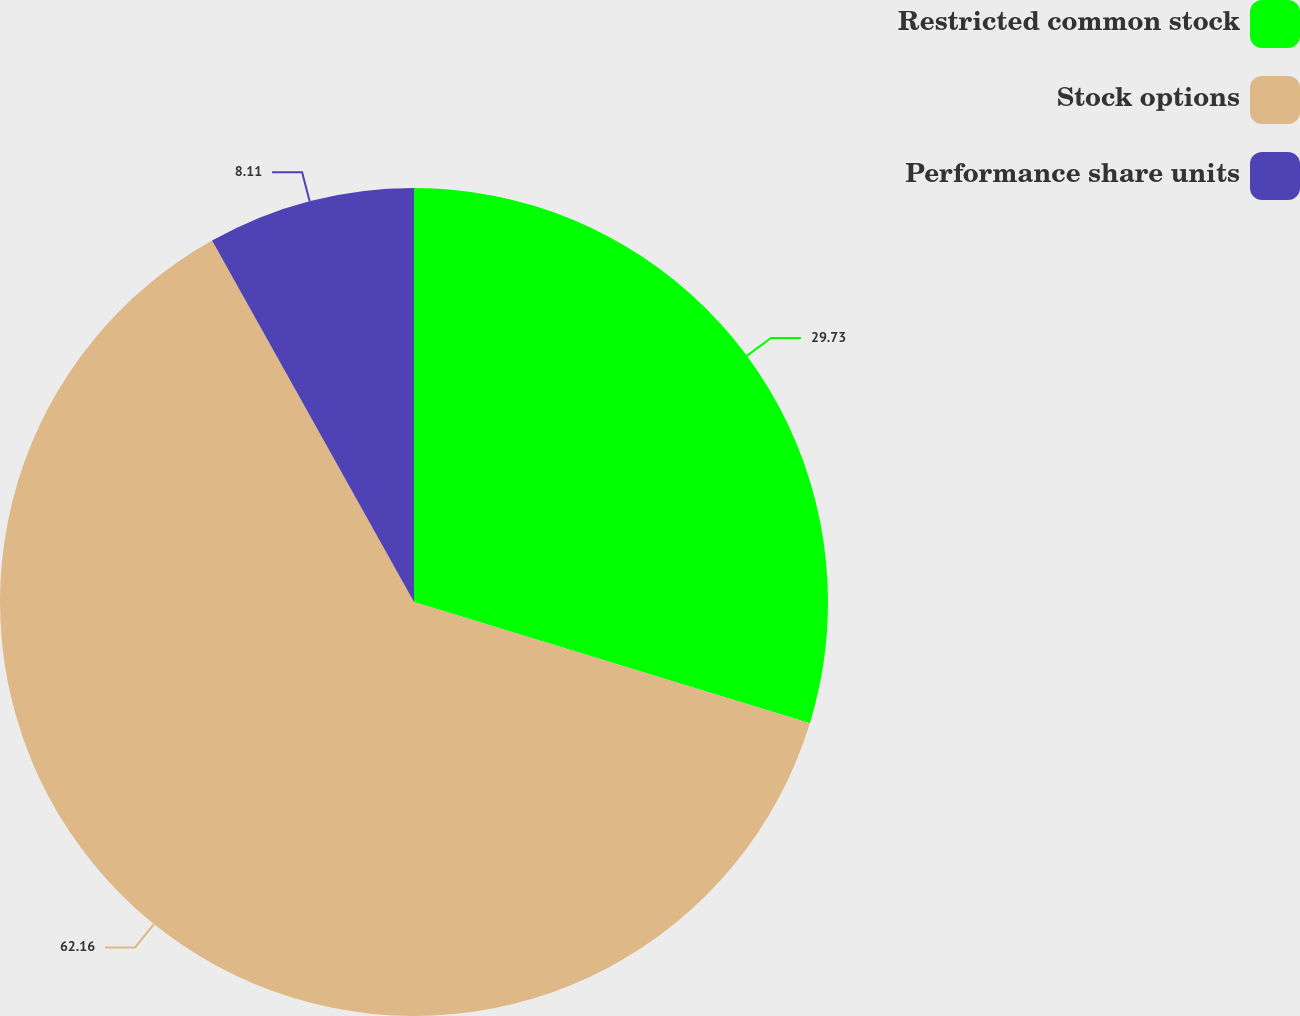<chart> <loc_0><loc_0><loc_500><loc_500><pie_chart><fcel>Restricted common stock<fcel>Stock options<fcel>Performance share units<nl><fcel>29.73%<fcel>62.16%<fcel>8.11%<nl></chart> 